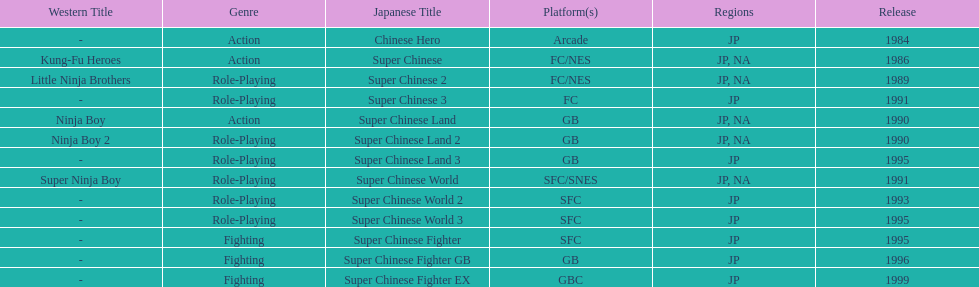How many super chinese international games were released 3. 